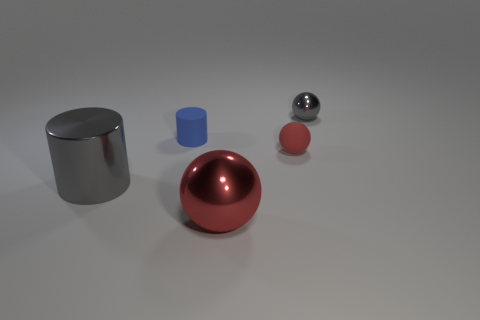Subtract all gray metallic balls. How many balls are left? 2 Subtract all red blocks. How many red balls are left? 2 Add 2 big red metal balls. How many objects exist? 7 Subtract all cylinders. How many objects are left? 3 Subtract all red balls. How many balls are left? 1 Subtract 2 spheres. How many spheres are left? 1 Subtract all cyan cylinders. Subtract all cyan cubes. How many cylinders are left? 2 Subtract all tiny red cylinders. Subtract all red balls. How many objects are left? 3 Add 3 large objects. How many large objects are left? 5 Add 1 red metal objects. How many red metal objects exist? 2 